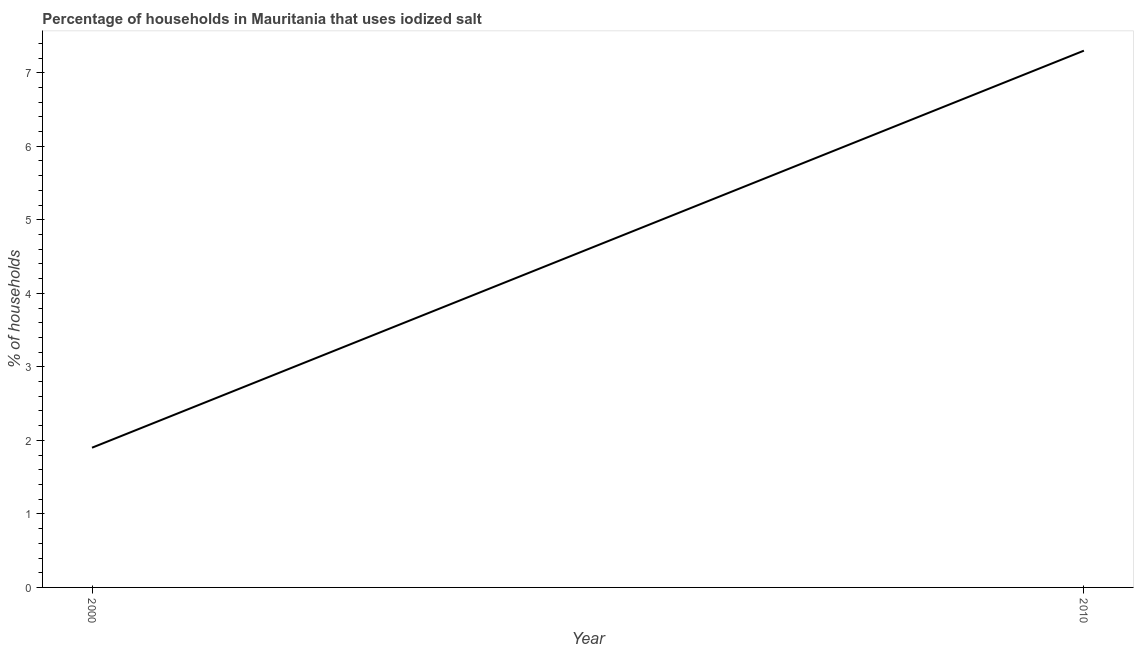Across all years, what is the maximum percentage of households where iodized salt is consumed?
Offer a very short reply. 7.3. In which year was the percentage of households where iodized salt is consumed minimum?
Offer a terse response. 2000. What is the difference between the percentage of households where iodized salt is consumed in 2000 and 2010?
Your answer should be very brief. -5.4. What is the average percentage of households where iodized salt is consumed per year?
Your response must be concise. 4.6. In how many years, is the percentage of households where iodized salt is consumed greater than 5.4 %?
Keep it short and to the point. 1. Do a majority of the years between 2010 and 2000 (inclusive) have percentage of households where iodized salt is consumed greater than 5.6 %?
Provide a short and direct response. No. What is the ratio of the percentage of households where iodized salt is consumed in 2000 to that in 2010?
Offer a terse response. 0.26. Is the percentage of households where iodized salt is consumed in 2000 less than that in 2010?
Give a very brief answer. Yes. In how many years, is the percentage of households where iodized salt is consumed greater than the average percentage of households where iodized salt is consumed taken over all years?
Offer a very short reply. 1. What is the title of the graph?
Your response must be concise. Percentage of households in Mauritania that uses iodized salt. What is the label or title of the X-axis?
Give a very brief answer. Year. What is the label or title of the Y-axis?
Provide a succinct answer. % of households. What is the difference between the % of households in 2000 and 2010?
Your answer should be very brief. -5.4. What is the ratio of the % of households in 2000 to that in 2010?
Provide a succinct answer. 0.26. 